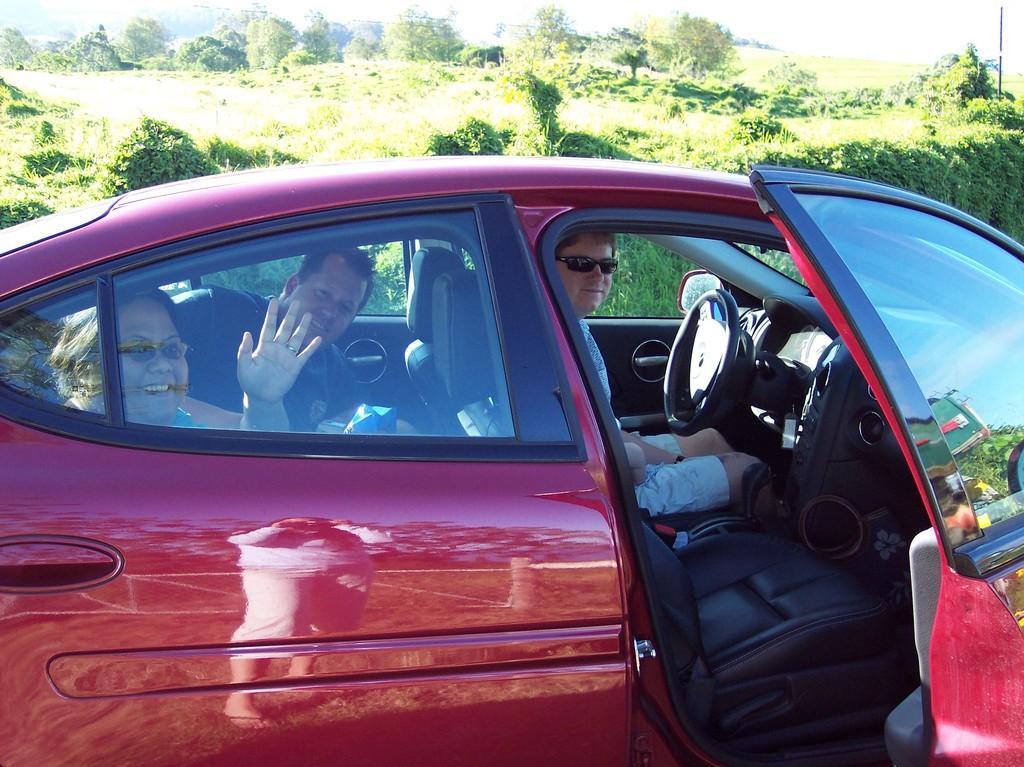How would you summarize this image in a sentence or two? In this image there is a car. There are people sitting inside the car. The car door is open. Behind the car there are trees and plants on the ground. 